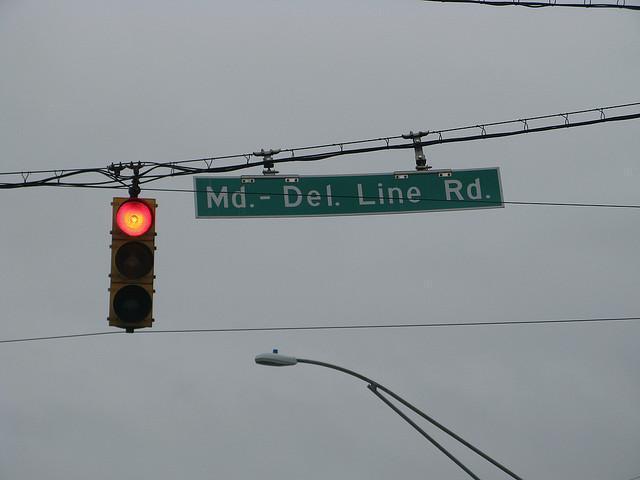How many giraffes are there?
Give a very brief answer. 0. 